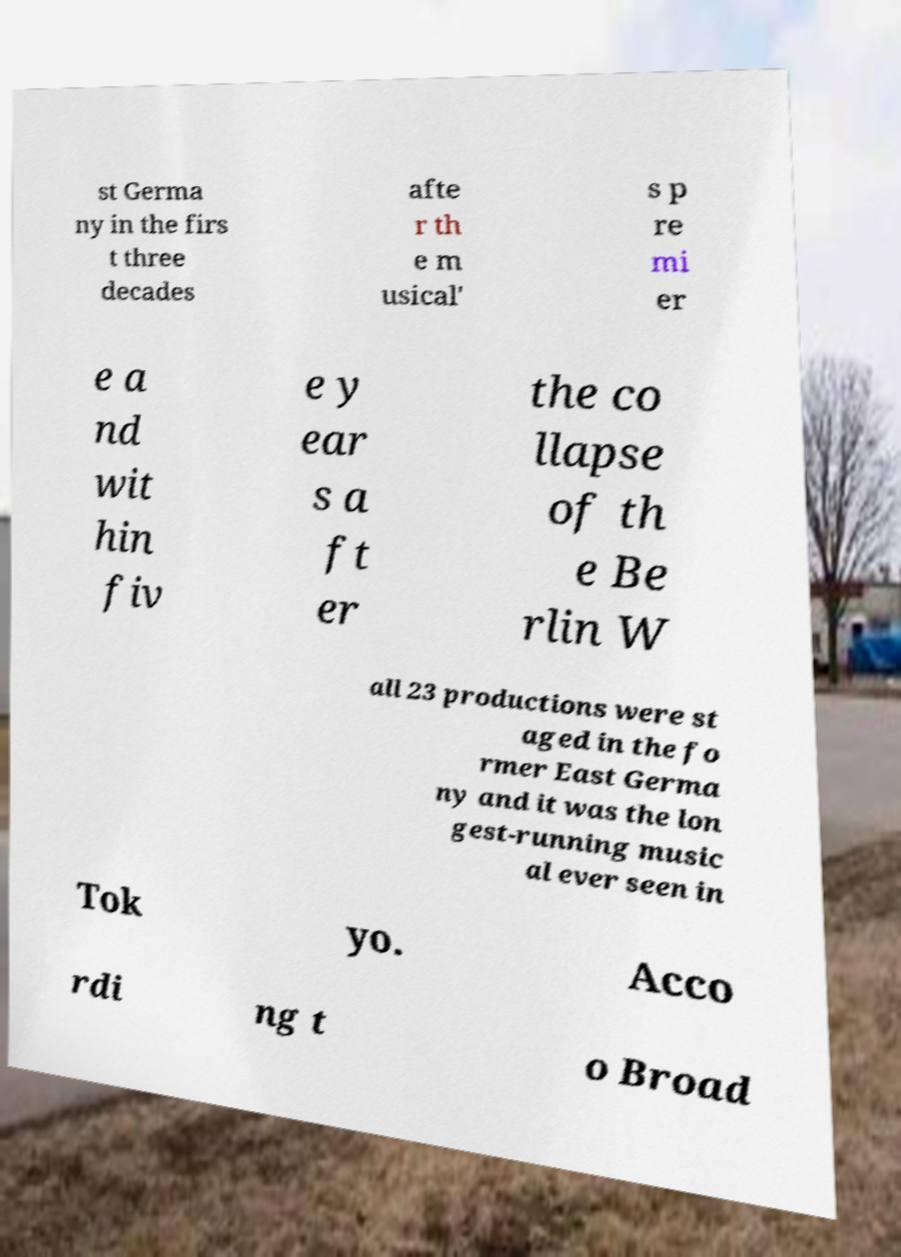Please identify and transcribe the text found in this image. st Germa ny in the firs t three decades afte r th e m usical' s p re mi er e a nd wit hin fiv e y ear s a ft er the co llapse of th e Be rlin W all 23 productions were st aged in the fo rmer East Germa ny and it was the lon gest-running music al ever seen in Tok yo. Acco rdi ng t o Broad 